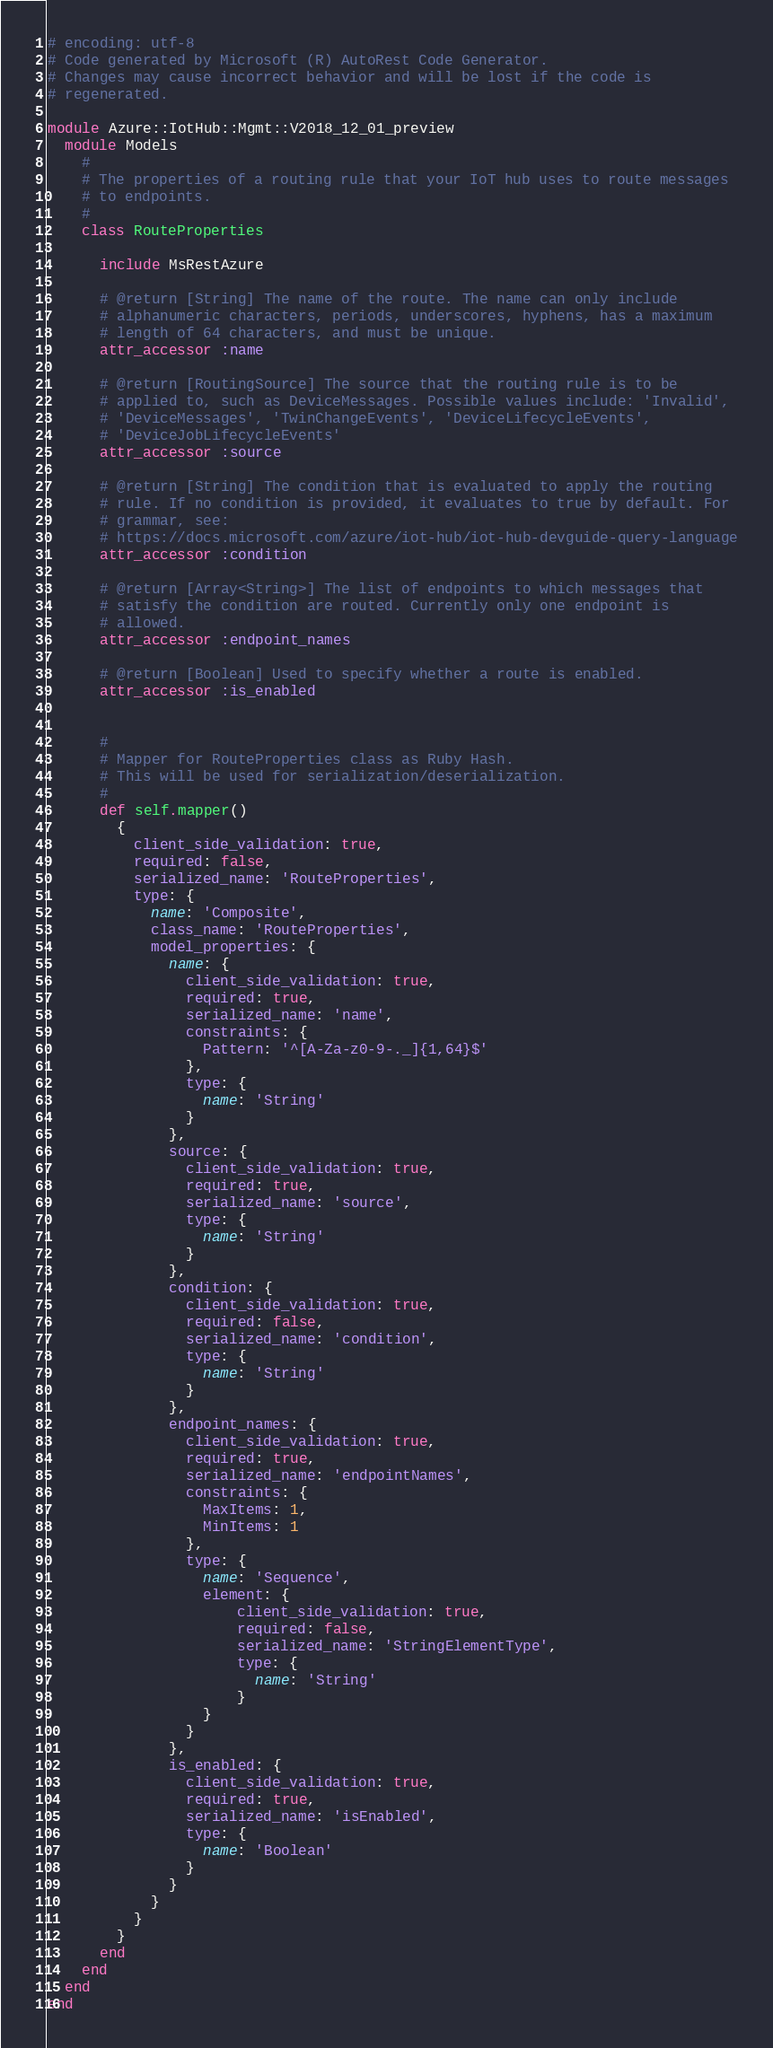Convert code to text. <code><loc_0><loc_0><loc_500><loc_500><_Ruby_># encoding: utf-8
# Code generated by Microsoft (R) AutoRest Code Generator.
# Changes may cause incorrect behavior and will be lost if the code is
# regenerated.

module Azure::IotHub::Mgmt::V2018_12_01_preview
  module Models
    #
    # The properties of a routing rule that your IoT hub uses to route messages
    # to endpoints.
    #
    class RouteProperties

      include MsRestAzure

      # @return [String] The name of the route. The name can only include
      # alphanumeric characters, periods, underscores, hyphens, has a maximum
      # length of 64 characters, and must be unique.
      attr_accessor :name

      # @return [RoutingSource] The source that the routing rule is to be
      # applied to, such as DeviceMessages. Possible values include: 'Invalid',
      # 'DeviceMessages', 'TwinChangeEvents', 'DeviceLifecycleEvents',
      # 'DeviceJobLifecycleEvents'
      attr_accessor :source

      # @return [String] The condition that is evaluated to apply the routing
      # rule. If no condition is provided, it evaluates to true by default. For
      # grammar, see:
      # https://docs.microsoft.com/azure/iot-hub/iot-hub-devguide-query-language
      attr_accessor :condition

      # @return [Array<String>] The list of endpoints to which messages that
      # satisfy the condition are routed. Currently only one endpoint is
      # allowed.
      attr_accessor :endpoint_names

      # @return [Boolean] Used to specify whether a route is enabled.
      attr_accessor :is_enabled


      #
      # Mapper for RouteProperties class as Ruby Hash.
      # This will be used for serialization/deserialization.
      #
      def self.mapper()
        {
          client_side_validation: true,
          required: false,
          serialized_name: 'RouteProperties',
          type: {
            name: 'Composite',
            class_name: 'RouteProperties',
            model_properties: {
              name: {
                client_side_validation: true,
                required: true,
                serialized_name: 'name',
                constraints: {
                  Pattern: '^[A-Za-z0-9-._]{1,64}$'
                },
                type: {
                  name: 'String'
                }
              },
              source: {
                client_side_validation: true,
                required: true,
                serialized_name: 'source',
                type: {
                  name: 'String'
                }
              },
              condition: {
                client_side_validation: true,
                required: false,
                serialized_name: 'condition',
                type: {
                  name: 'String'
                }
              },
              endpoint_names: {
                client_side_validation: true,
                required: true,
                serialized_name: 'endpointNames',
                constraints: {
                  MaxItems: 1,
                  MinItems: 1
                },
                type: {
                  name: 'Sequence',
                  element: {
                      client_side_validation: true,
                      required: false,
                      serialized_name: 'StringElementType',
                      type: {
                        name: 'String'
                      }
                  }
                }
              },
              is_enabled: {
                client_side_validation: true,
                required: true,
                serialized_name: 'isEnabled',
                type: {
                  name: 'Boolean'
                }
              }
            }
          }
        }
      end
    end
  end
end
</code> 